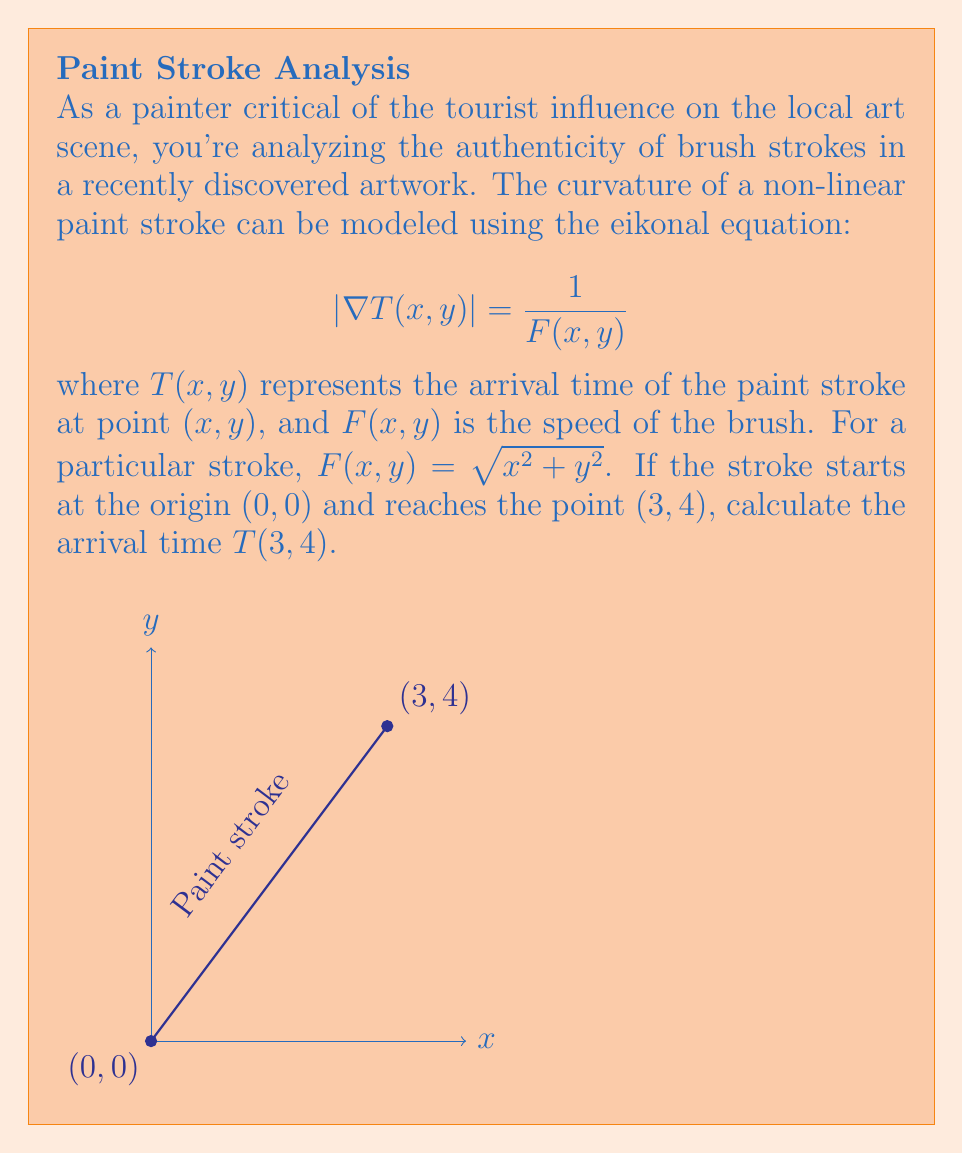Could you help me with this problem? Let's approach this step-by-step:

1) The eikonal equation for this problem is:

   $$|\nabla T(x,y)| = \frac{1}{\sqrt{x^2 + y^2}}$$

2) For a radially symmetric solution (which is reasonable given the form of $F(x,y)$), we can assume $T(x,y)$ is a function of $r = \sqrt{x^2 + y^2}$ only. Let's call this function $u(r)$.

3) In this case, $\nabla T = u'(r) \frac{\mathbf{r}}{r}$, so $|\nabla T| = |u'(r)|$.

4) Substituting into the eikonal equation:

   $$|u'(r)| = \frac{1}{r}$$

5) Assuming $u'(r)$ is positive (as time increases with distance), we can remove the absolute value signs:

   $$u'(r) = \frac{1}{r}$$

6) Integrating both sides:

   $$u(r) = \ln(r) + C$$

7) To determine $C$, we use the initial condition that $T(0,0) = 0$. However, $\ln(0)$ is undefined, so we need to be careful. We can interpret this as the limit as $r$ approaches 0:

   $$\lim_{r \to 0} (\ln(r) + C) = 0$$

   This implies $C = 0$.

8) Therefore, our solution is:

   $$T(x,y) = \ln(\sqrt{x^2 + y^2})$$

9) For the point (3,4):

   $$T(3,4) = \ln(\sqrt{3^2 + 4^2}) = \ln(5)$$
Answer: $\ln(5)$ 